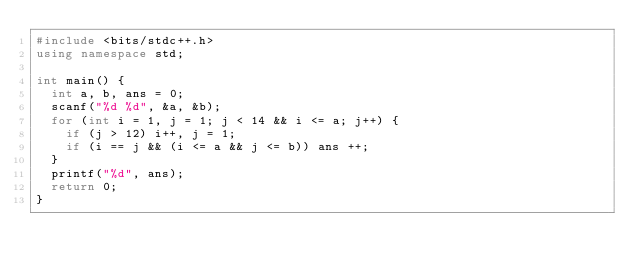<code> <loc_0><loc_0><loc_500><loc_500><_C++_>#include <bits/stdc++.h>
using namespace std;

int main() {
	int a, b, ans = 0;
	scanf("%d %d", &a, &b);
	for (int i = 1, j = 1; j < 14 && i <= a; j++) {
		if (j > 12) i++, j = 1;
		if (i == j && (i <= a && j <= b)) ans ++;
	}
	printf("%d", ans);
	return 0;
}</code> 